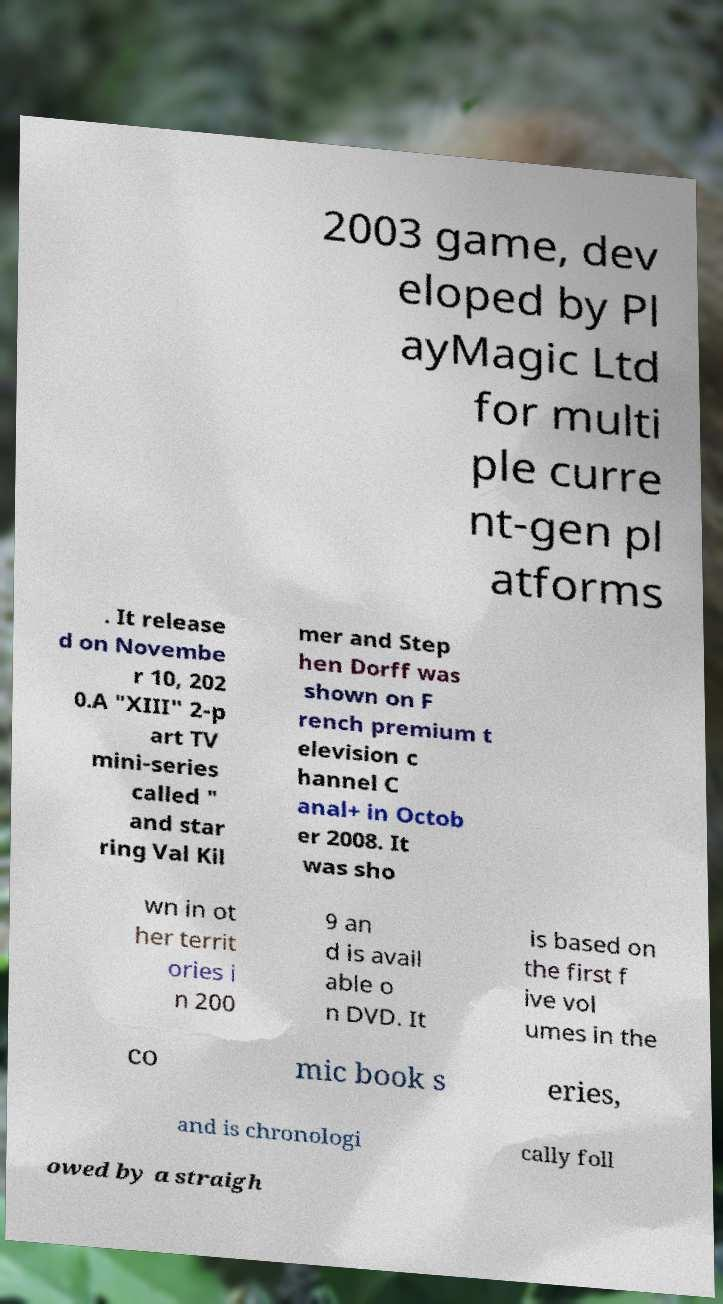Please identify and transcribe the text found in this image. 2003 game, dev eloped by Pl ayMagic Ltd for multi ple curre nt-gen pl atforms . It release d on Novembe r 10, 202 0.A "XIII" 2-p art TV mini-series called " and star ring Val Kil mer and Step hen Dorff was shown on F rench premium t elevision c hannel C anal+ in Octob er 2008. It was sho wn in ot her territ ories i n 200 9 an d is avail able o n DVD. It is based on the first f ive vol umes in the co mic book s eries, and is chronologi cally foll owed by a straigh 